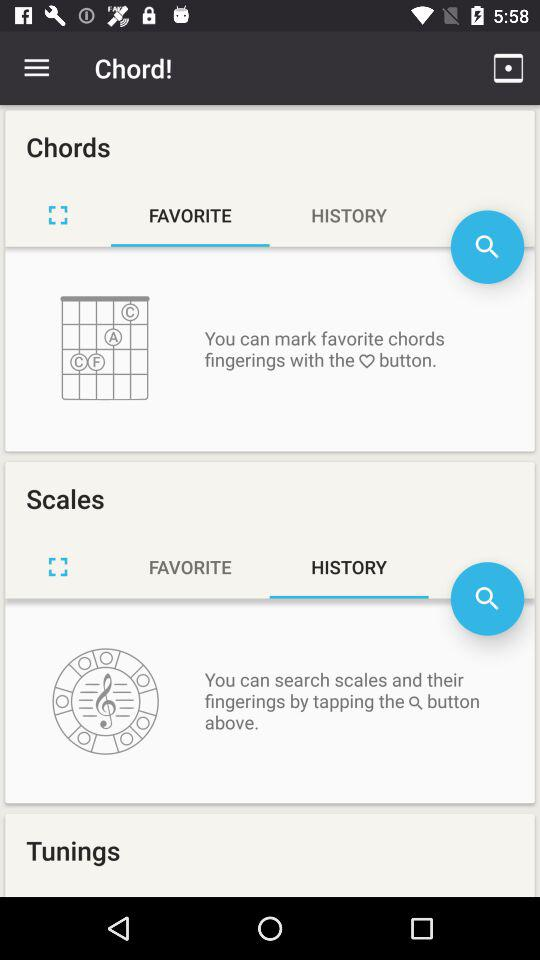What's the selected option in "Scales"? The selected option is "HISTORY". 